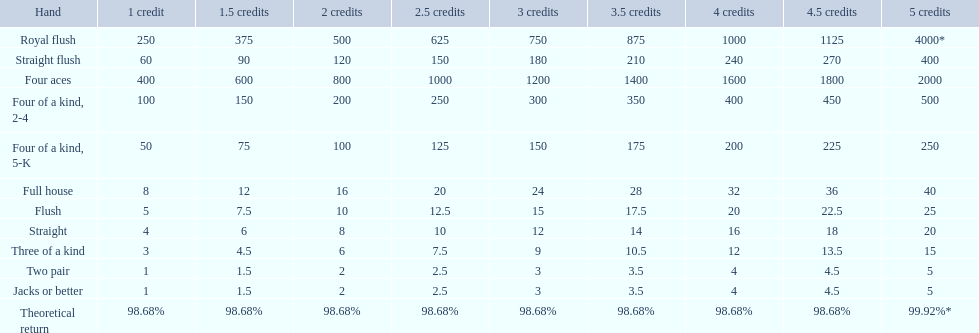What is the values in the 5 credits area? 4000*, 400, 2000, 500, 250, 40, 25, 20, 15, 5, 5. Which of these is for a four of a kind? 500, 250. What is the higher value? 500. What hand is this for Four of a kind, 2-4. What are each of the hands? Royal flush, Straight flush, Four aces, Four of a kind, 2-4, Four of a kind, 5-K, Full house, Flush, Straight, Three of a kind, Two pair, Jacks or better, Theoretical return. Which hand ranks higher between straights and flushes? Flush. 